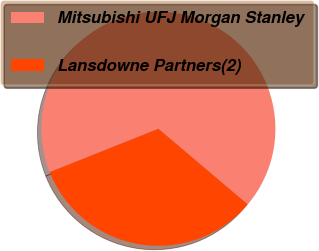Convert chart. <chart><loc_0><loc_0><loc_500><loc_500><pie_chart><fcel>Mitsubishi UFJ Morgan Stanley<fcel>Lansdowne Partners(2)<nl><fcel>67.23%<fcel>32.77%<nl></chart> 